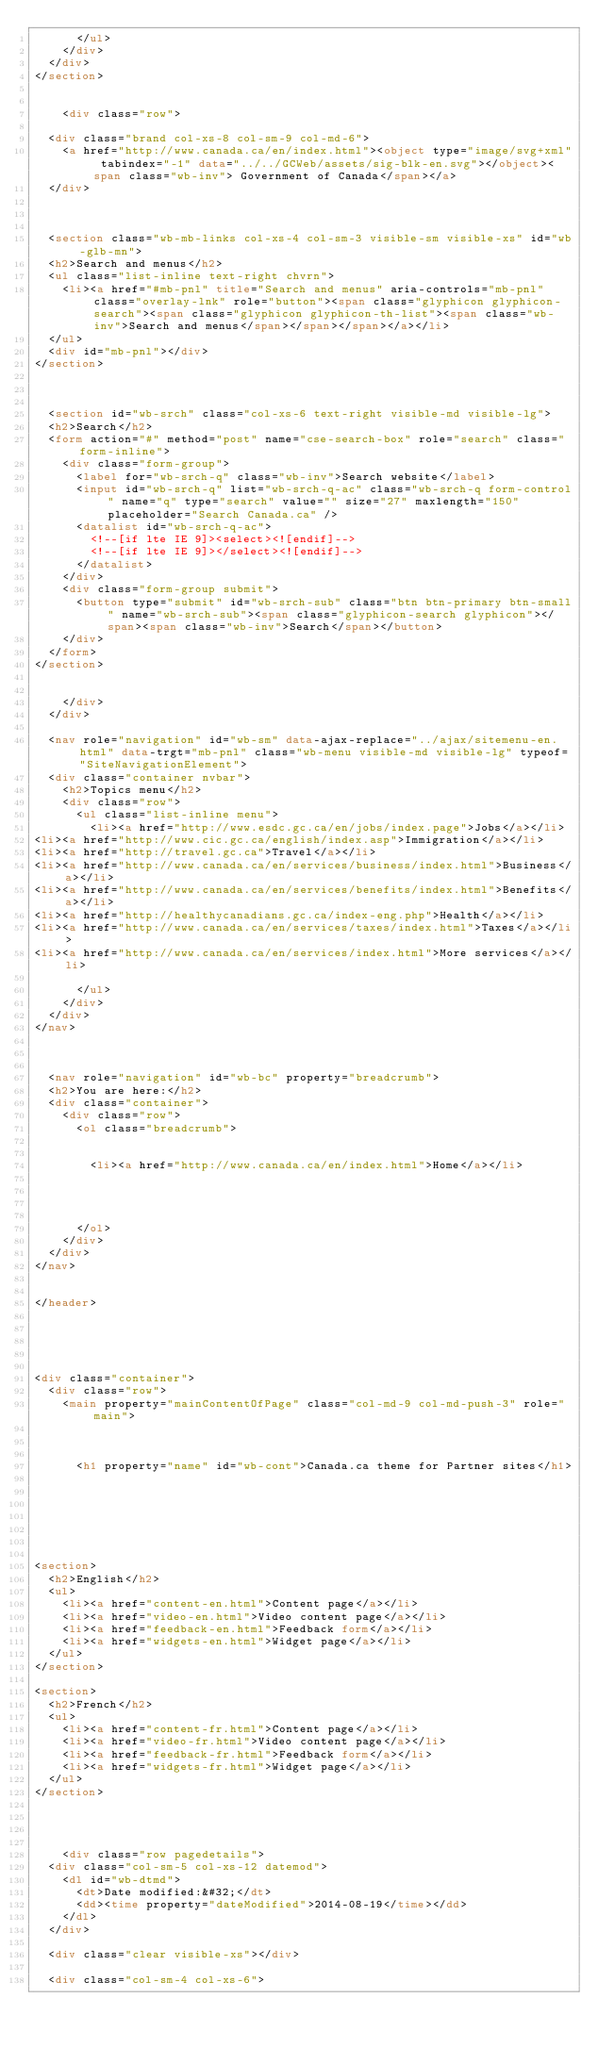<code> <loc_0><loc_0><loc_500><loc_500><_HTML_>			</ul>
		</div>
	</div>
</section>


		<div class="row">
			
	<div class="brand col-xs-8 col-sm-9 col-md-6">
		<a href="http://www.canada.ca/en/index.html"><object type="image/svg+xml" tabindex="-1" data="../../GCWeb/assets/sig-blk-en.svg"></object><span class="wb-inv"> Government of Canada</span></a>
	</div>



	<section class="wb-mb-links col-xs-4 col-sm-3 visible-sm visible-xs" id="wb-glb-mn">
	<h2>Search and menus</h2>
	<ul class="list-inline text-right chvrn">
		<li><a href="#mb-pnl" title="Search and menus" aria-controls="mb-pnl" class="overlay-lnk" role="button"><span class="glyphicon glyphicon-search"><span class="glyphicon glyphicon-th-list"><span class="wb-inv">Search and menus</span></span></span></a></li>
	</ul>
	<div id="mb-pnl"></div>
</section>



	<section id="wb-srch" class="col-xs-6 text-right visible-md visible-lg">
	<h2>Search</h2>
	<form action="#" method="post" name="cse-search-box" role="search" class="form-inline">
		<div class="form-group">
			<label for="wb-srch-q" class="wb-inv">Search website</label>
			<input id="wb-srch-q" list="wb-srch-q-ac" class="wb-srch-q form-control" name="q" type="search" value="" size="27" maxlength="150" placeholder="Search Canada.ca" />
			<datalist id="wb-srch-q-ac">
				<!--[if lte IE 9]><select><![endif]-->
				<!--[if lte IE 9]></select><![endif]-->
			</datalist>
		</div>
		<div class="form-group submit">
			<button type="submit" id="wb-srch-sub" class="btn btn-primary btn-small" name="wb-srch-sub"><span class="glyphicon-search glyphicon"></span><span class="wb-inv">Search</span></button>
		</div>
	</form>
</section>


		</div>
	</div>

	<nav role="navigation" id="wb-sm" data-ajax-replace="../ajax/sitemenu-en.html" data-trgt="mb-pnl" class="wb-menu visible-md visible-lg" typeof="SiteNavigationElement">
	<div class="container nvbar">
		<h2>Topics menu</h2>
		<div class="row">
			<ul class="list-inline menu">
				<li><a href="http://www.esdc.gc.ca/en/jobs/index.page">Jobs</a></li>
<li><a href="http://www.cic.gc.ca/english/index.asp">Immigration</a></li>
<li><a href="http://travel.gc.ca">Travel</a></li>
<li><a href="http://www.canada.ca/en/services/business/index.html">Business</a></li>
<li><a href="http://www.canada.ca/en/services/benefits/index.html">Benefits</a></li>
<li><a href="http://healthycanadians.gc.ca/index-eng.php">Health</a></li>
<li><a href="http://www.canada.ca/en/services/taxes/index.html">Taxes</a></li>
<li><a href="http://www.canada.ca/en/services/index.html">More services</a></li>

			</ul>
		</div>
	</div>
</nav>



	<nav role="navigation" id="wb-bc" property="breadcrumb">
	<h2>You are here:</h2>
	<div class="container">
		<div class="row">
			<ol class="breadcrumb">
				
	
				<li><a href="http://www.canada.ca/en/index.html">Home</a></li>

	


			</ol>
		</div>
	</div>
</nav>


</header>





<div class="container">
	<div class="row">
		<main property="mainContentOfPage" class="col-md-9 col-md-push-3" role="main">



			<h1 property="name" id="wb-cont">Canada.ca theme for Partner sites</h1>


			



			
<section>
	<h2>English</h2>
	<ul>
		<li><a href="content-en.html">Content page</a></li>
		<li><a href="video-en.html">Video content page</a></li>
		<li><a href="feedback-en.html">Feedback form</a></li>
		<li><a href="widgets-en.html">Widget page</a></li>
	</ul>
</section>

<section>
	<h2>French</h2>
	<ul>
		<li><a href="content-fr.html">Content page</a></li>
		<li><a href="video-fr.html">Video content page</a></li>
		<li><a href="feedback-fr.html">Feedback form</a></li>
		<li><a href="widgets-fr.html">Widget page</a></li>
	</ul>
</section>



	
		<div class="row pagedetails">
	<div class="col-sm-5 col-xs-12 datemod">
		<dl id="wb-dtmd">
			<dt>Date modified:&#32;</dt>
			<dd><time property="dateModified">2014-08-19</time></dd>
		</dl>
	</div>

	<div class="clear visible-xs"></div>

	<div class="col-sm-4 col-xs-6"></code> 